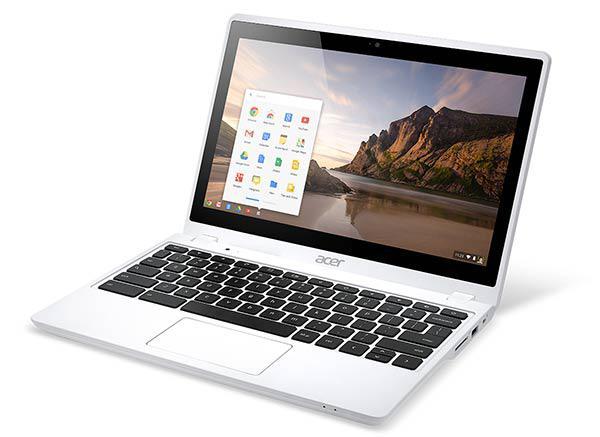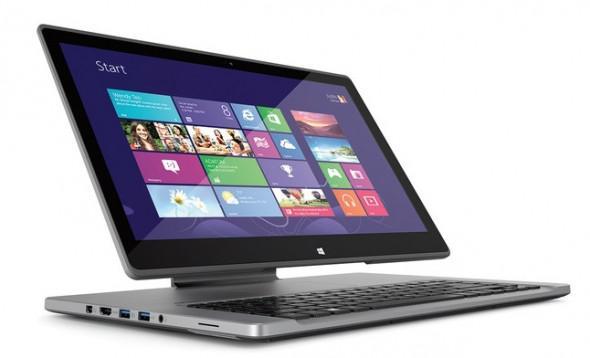The first image is the image on the left, the second image is the image on the right. Assess this claim about the two images: "The laptop on the right displays the tiles from the operating system Windows.". Correct or not? Answer yes or no. Yes. 